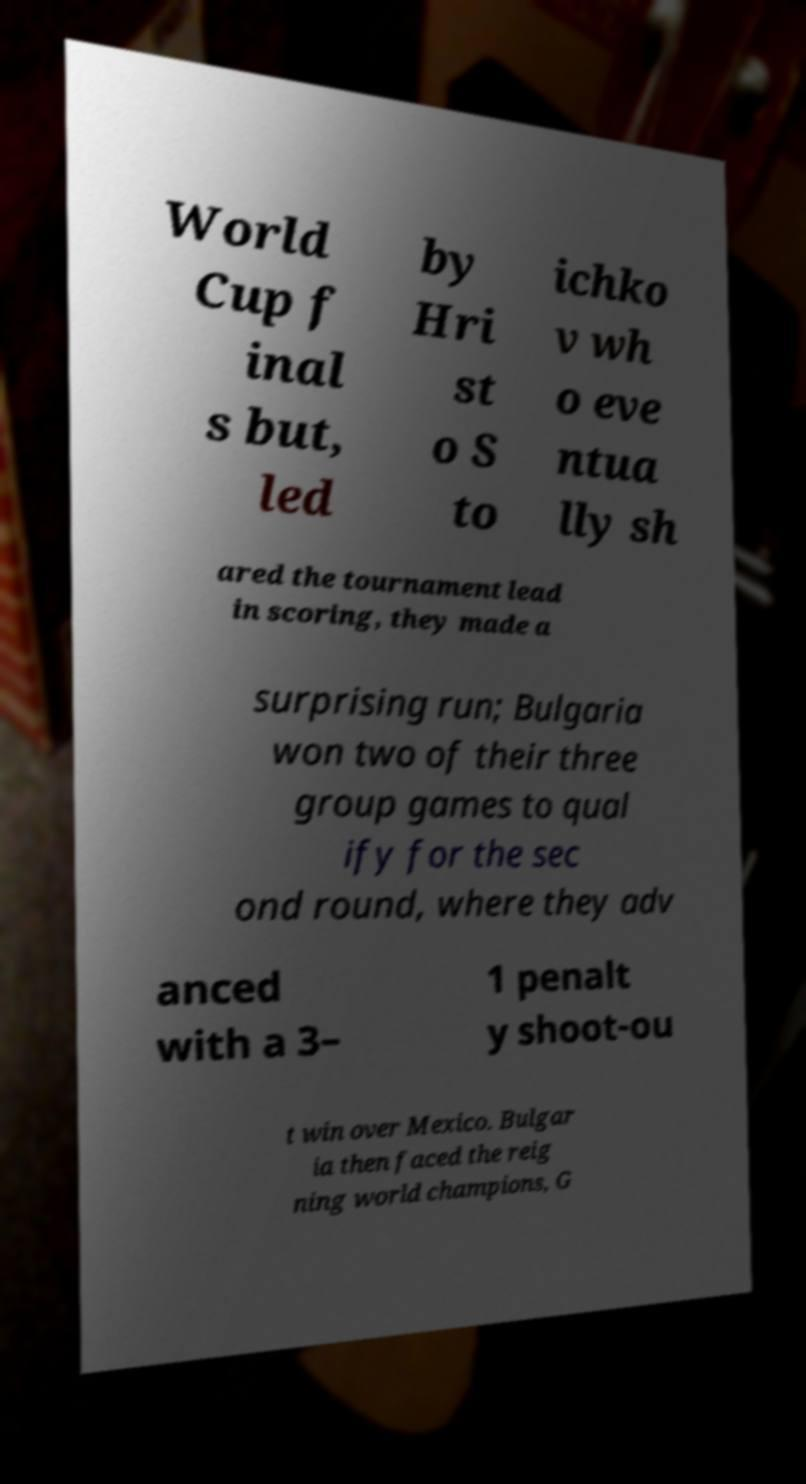I need the written content from this picture converted into text. Can you do that? World Cup f inal s but, led by Hri st o S to ichko v wh o eve ntua lly sh ared the tournament lead in scoring, they made a surprising run; Bulgaria won two of their three group games to qual ify for the sec ond round, where they adv anced with a 3– 1 penalt y shoot-ou t win over Mexico. Bulgar ia then faced the reig ning world champions, G 